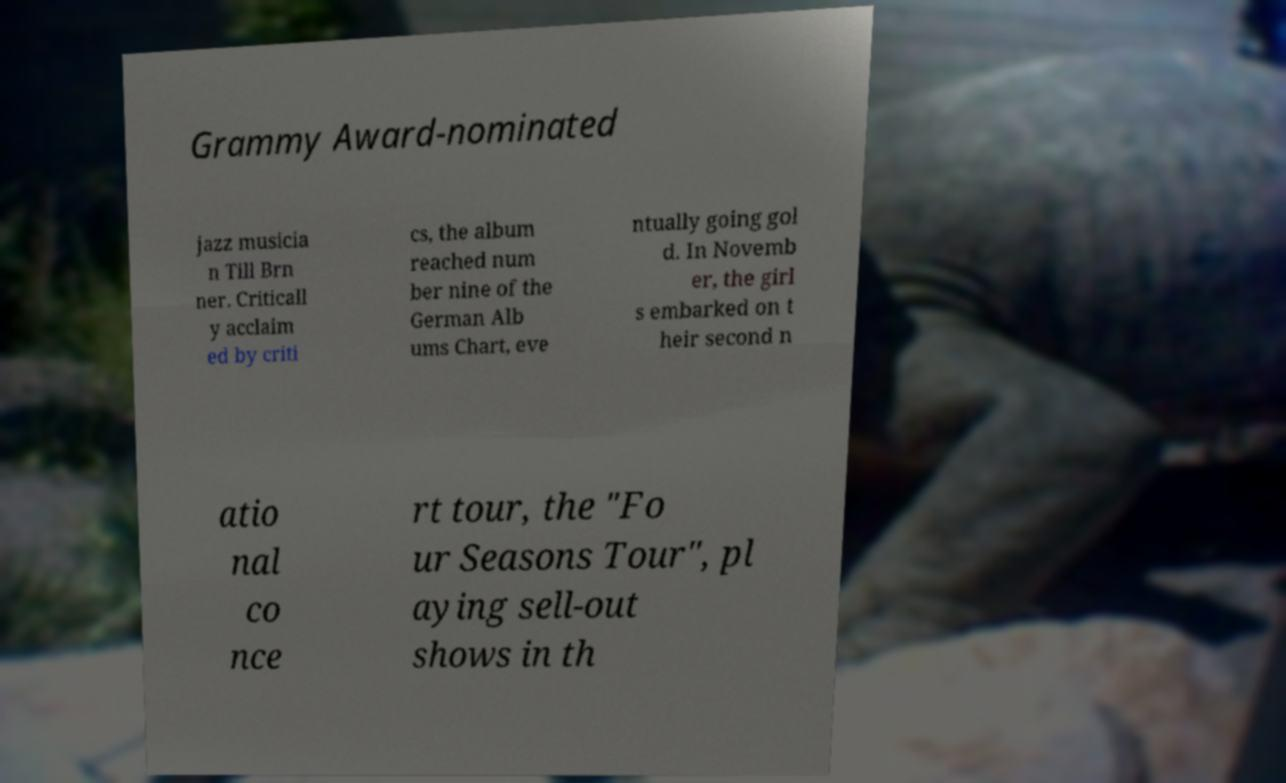Can you read and provide the text displayed in the image?This photo seems to have some interesting text. Can you extract and type it out for me? Grammy Award-nominated jazz musicia n Till Brn ner. Criticall y acclaim ed by criti cs, the album reached num ber nine of the German Alb ums Chart, eve ntually going gol d. In Novemb er, the girl s embarked on t heir second n atio nal co nce rt tour, the "Fo ur Seasons Tour", pl aying sell-out shows in th 